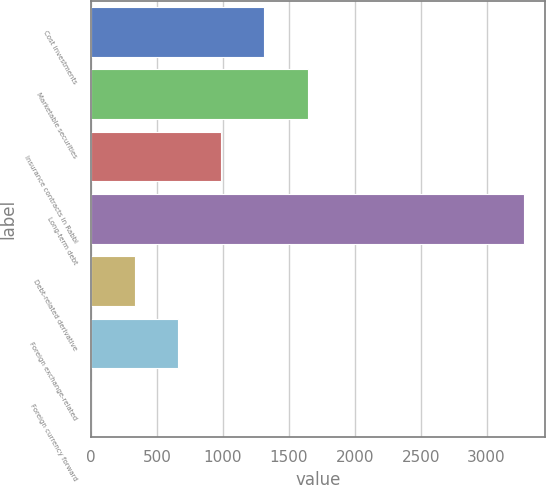Convert chart to OTSL. <chart><loc_0><loc_0><loc_500><loc_500><bar_chart><fcel>Cost investments<fcel>Marketable securities<fcel>Insurance contracts in Rabbi<fcel>Long-term debt<fcel>Debt-related derivative<fcel>Foreign exchange-related<fcel>Foreign currency forward<nl><fcel>1314.6<fcel>1642.5<fcel>986.7<fcel>3282<fcel>330.9<fcel>658.8<fcel>3<nl></chart> 